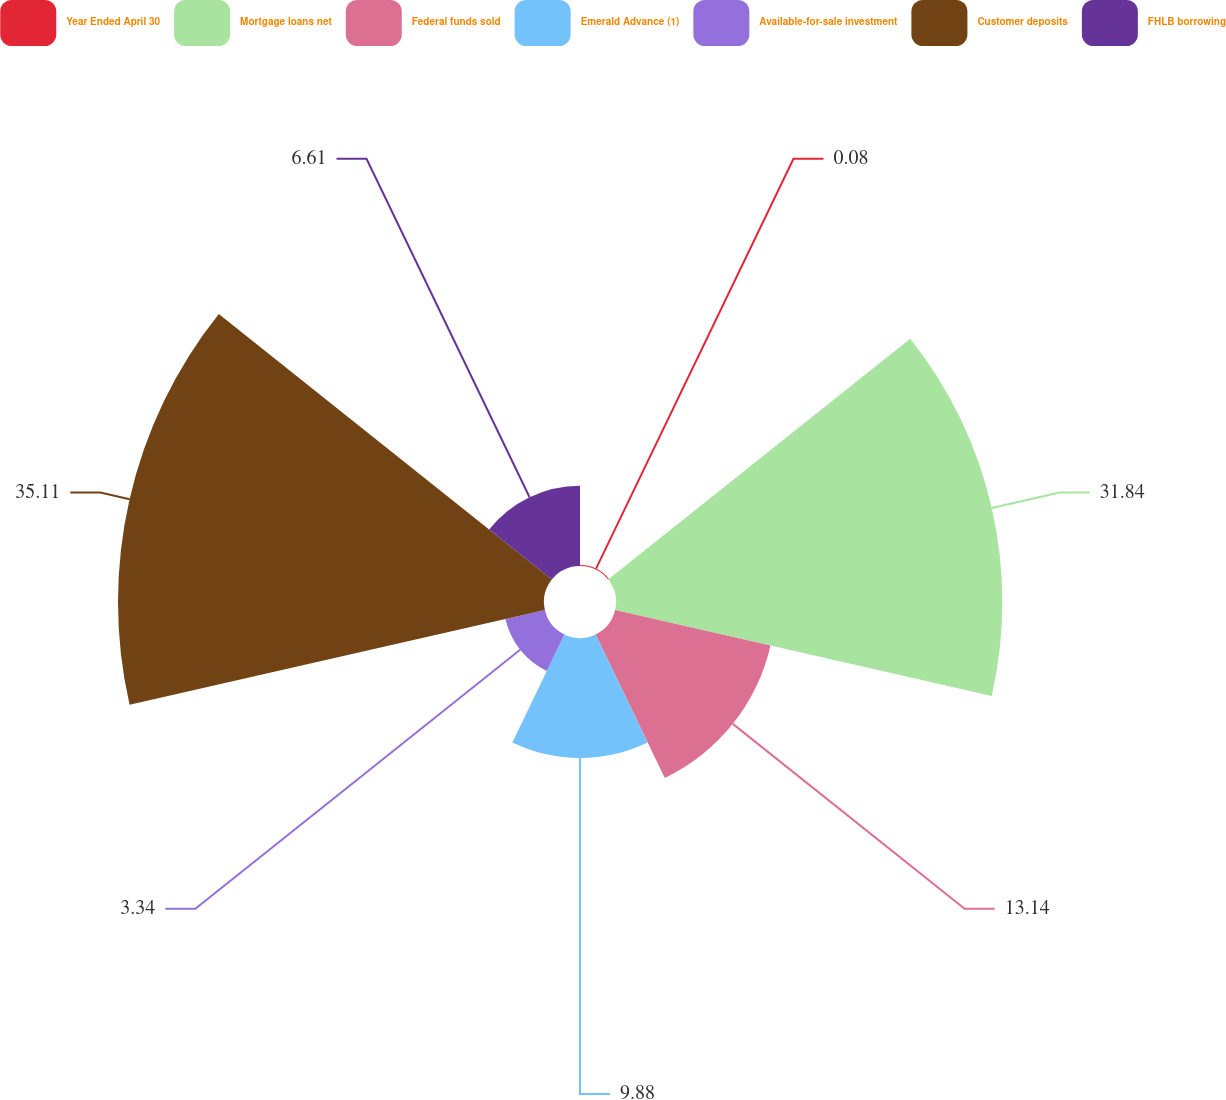Convert chart to OTSL. <chart><loc_0><loc_0><loc_500><loc_500><pie_chart><fcel>Year Ended April 30<fcel>Mortgage loans net<fcel>Federal funds sold<fcel>Emerald Advance (1)<fcel>Available-for-sale investment<fcel>Customer deposits<fcel>FHLB borrowing<nl><fcel>0.08%<fcel>31.84%<fcel>13.14%<fcel>9.88%<fcel>3.34%<fcel>35.11%<fcel>6.61%<nl></chart> 